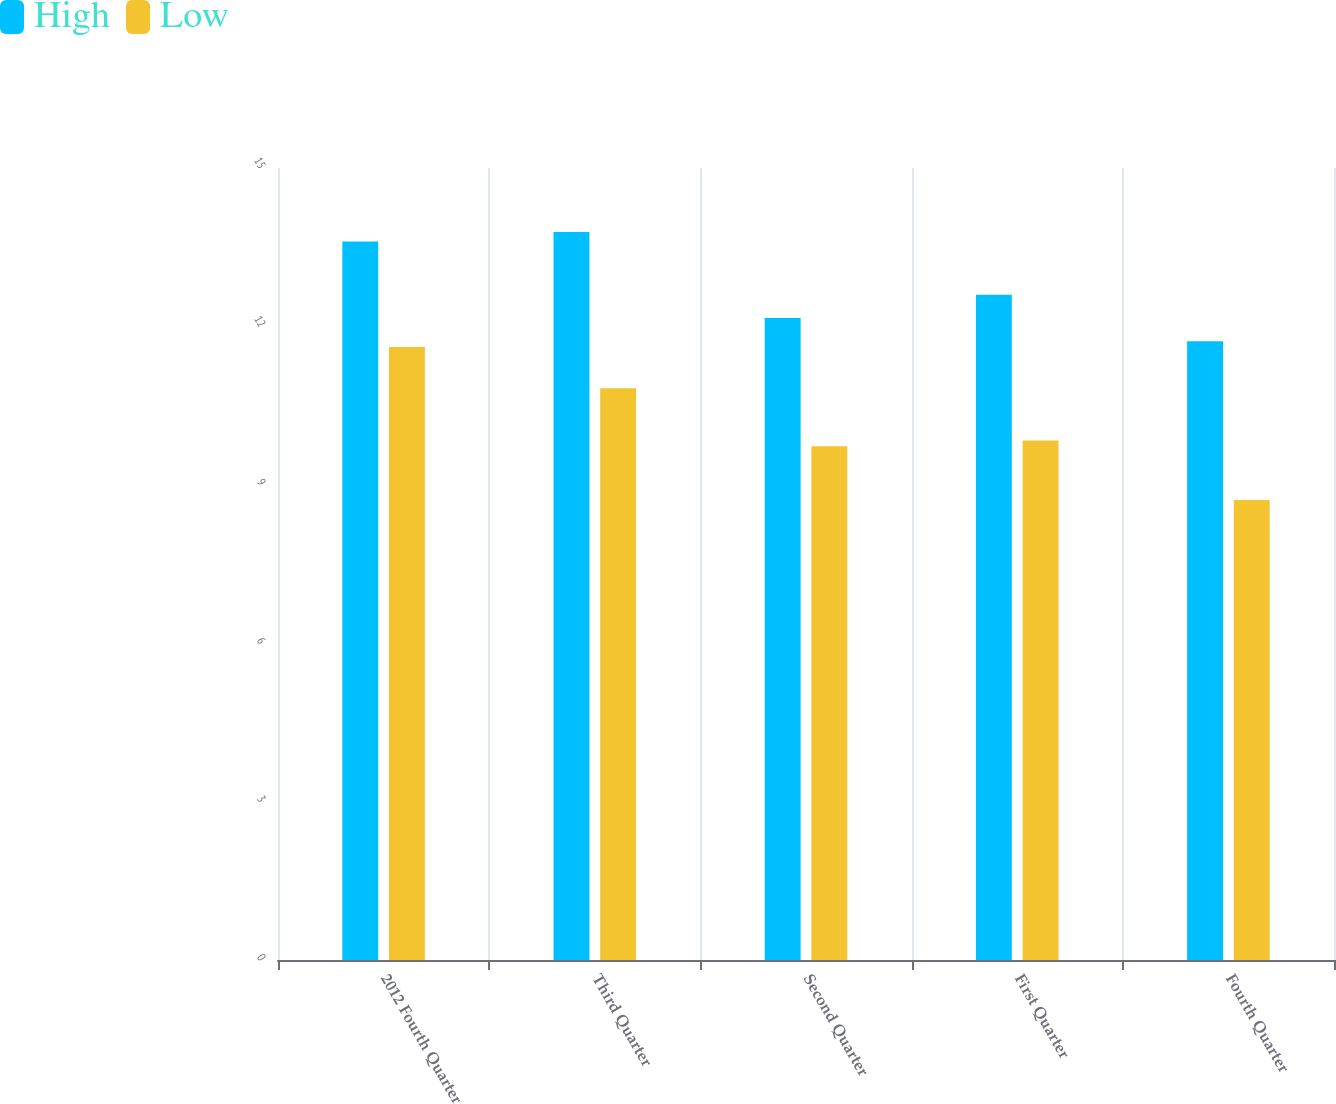Convert chart. <chart><loc_0><loc_0><loc_500><loc_500><stacked_bar_chart><ecel><fcel>2012 Fourth Quarter<fcel>Third Quarter<fcel>Second Quarter<fcel>First Quarter<fcel>Fourth Quarter<nl><fcel>High<fcel>13.61<fcel>13.79<fcel>12.16<fcel>12.6<fcel>11.72<nl><fcel>Low<fcel>11.61<fcel>10.83<fcel>9.73<fcel>9.84<fcel>8.71<nl></chart> 